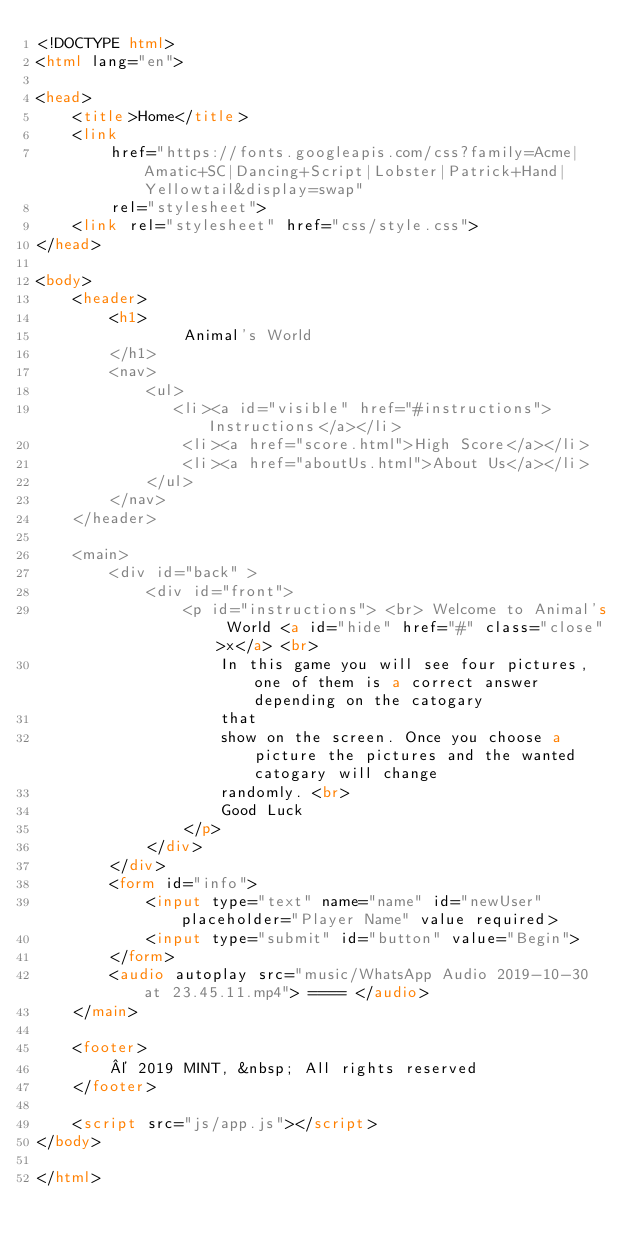<code> <loc_0><loc_0><loc_500><loc_500><_HTML_><!DOCTYPE html>
<html lang="en">

<head>
    <title>Home</title>
    <link
        href="https://fonts.googleapis.com/css?family=Acme|Amatic+SC|Dancing+Script|Lobster|Patrick+Hand|Yellowtail&display=swap"
        rel="stylesheet">
    <link rel="stylesheet" href="css/style.css">
</head>

<body>
    <header>
        <h1>
                Animal's World
        </h1>
        <nav>
            <ul>
               <li><a id="visible" href="#instructions">Instructions</a></li>
                <li><a href="score.html">High Score</a></li>
                <li><a href="aboutUs.html">About Us</a></li>
            </ul>
        </nav>
    </header>

    <main>
        <div id="back" >
            <div id="front">
                <p id="instructions"> <br> Welcome to Animal's World <a id="hide" href="#" class="close">x</a> <br>
                    In this game you will see four pictures, one of them is a correct answer depending on the catogary
                    that
                    show on the screen. Once you choose a picture the pictures and the wanted catogary will change
                    randomly. <br>
                    Good Luck
                </p>
            </div>
        </div>
        <form id="info">
            <input type="text" name="name" id="newUser" placeholder="Player Name" value required>
            <input type="submit" id="button" value="Begin">
        </form>
        <audio autoplay src="music/WhatsApp Audio 2019-10-30 at 23.45.11.mp4"> ==== </audio>
    </main>

    <footer>
        © 2019 MINT, &nbsp; All rights reserved
    </footer>

    <script src="js/app.js"></script>
</body>

</html></code> 